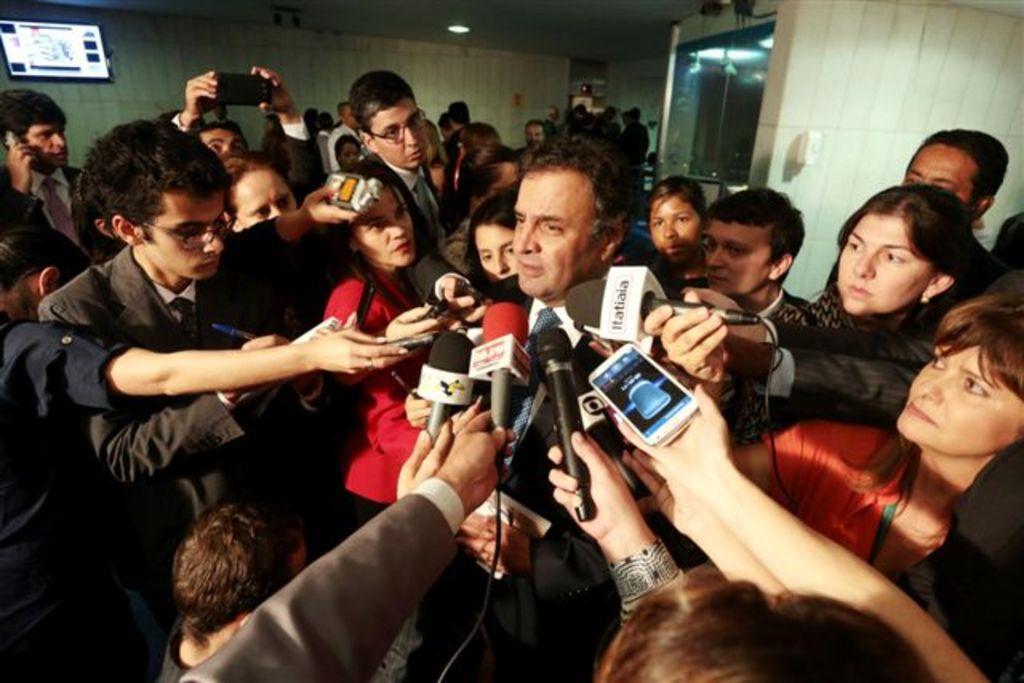How would you summarize this image in a sentence or two? In the image few people are standing and holding a microphones. Behind them there is a wall and screen. 